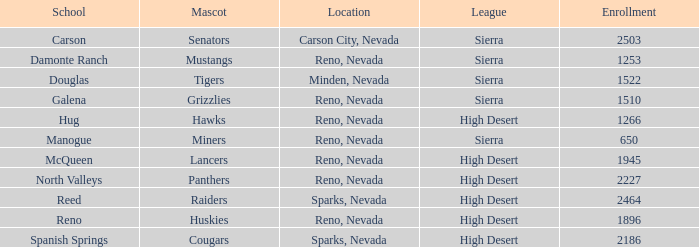In which city and state can the lancers mascot be found? Reno, Nevada. 